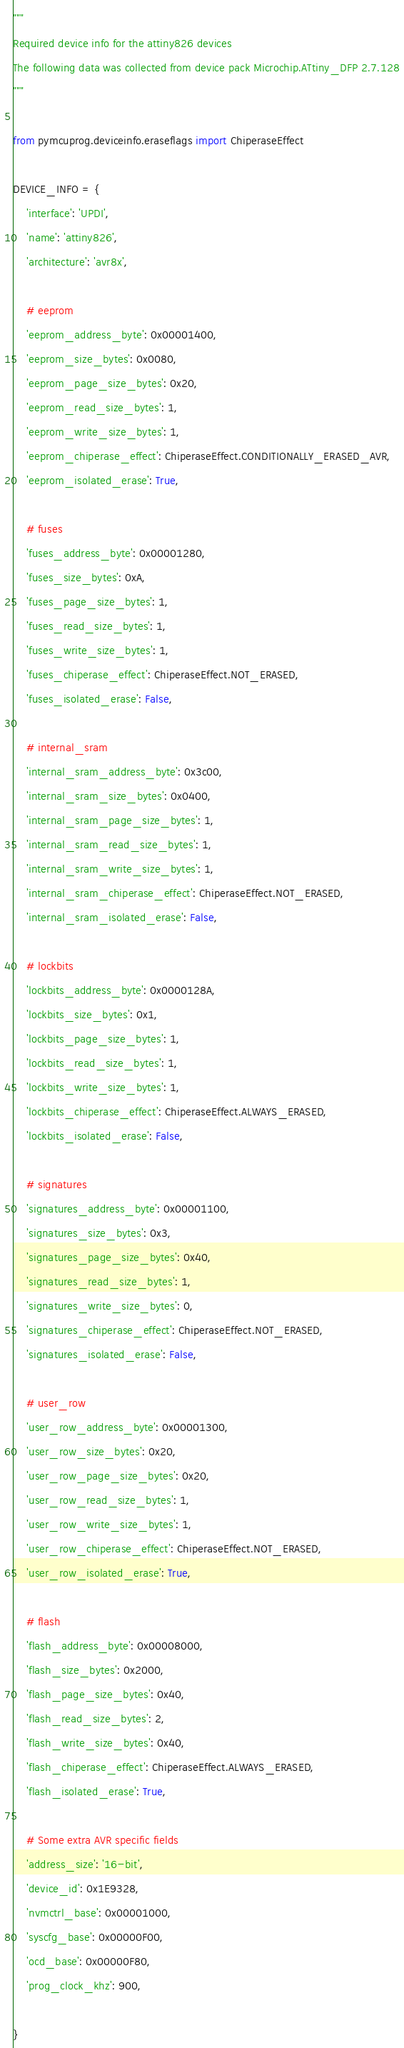Convert code to text. <code><loc_0><loc_0><loc_500><loc_500><_Python_>
"""
Required device info for the attiny826 devices
The following data was collected from device pack Microchip.ATtiny_DFP 2.7.128
"""

from pymcuprog.deviceinfo.eraseflags import ChiperaseEffect

DEVICE_INFO = {
    'interface': 'UPDI',
    'name': 'attiny826',
    'architecture': 'avr8x',

    # eeprom
    'eeprom_address_byte': 0x00001400,
    'eeprom_size_bytes': 0x0080,
    'eeprom_page_size_bytes': 0x20,
    'eeprom_read_size_bytes': 1,
    'eeprom_write_size_bytes': 1,
    'eeprom_chiperase_effect': ChiperaseEffect.CONDITIONALLY_ERASED_AVR,
    'eeprom_isolated_erase': True,

    # fuses
    'fuses_address_byte': 0x00001280,
    'fuses_size_bytes': 0xA,
    'fuses_page_size_bytes': 1,
    'fuses_read_size_bytes': 1,
    'fuses_write_size_bytes': 1,
    'fuses_chiperase_effect': ChiperaseEffect.NOT_ERASED,
    'fuses_isolated_erase': False,

    # internal_sram
    'internal_sram_address_byte': 0x3c00,
    'internal_sram_size_bytes': 0x0400,
    'internal_sram_page_size_bytes': 1,
    'internal_sram_read_size_bytes': 1,
    'internal_sram_write_size_bytes': 1,
    'internal_sram_chiperase_effect': ChiperaseEffect.NOT_ERASED,
    'internal_sram_isolated_erase': False,

    # lockbits
    'lockbits_address_byte': 0x0000128A,
    'lockbits_size_bytes': 0x1,
    'lockbits_page_size_bytes': 1,
    'lockbits_read_size_bytes': 1,
    'lockbits_write_size_bytes': 1,
    'lockbits_chiperase_effect': ChiperaseEffect.ALWAYS_ERASED,
    'lockbits_isolated_erase': False,

    # signatures
    'signatures_address_byte': 0x00001100,
    'signatures_size_bytes': 0x3,
    'signatures_page_size_bytes': 0x40,
    'signatures_read_size_bytes': 1,
    'signatures_write_size_bytes': 0,
    'signatures_chiperase_effect': ChiperaseEffect.NOT_ERASED,
    'signatures_isolated_erase': False,

    # user_row
    'user_row_address_byte': 0x00001300,
    'user_row_size_bytes': 0x20,
    'user_row_page_size_bytes': 0x20,
    'user_row_read_size_bytes': 1,
    'user_row_write_size_bytes': 1,
    'user_row_chiperase_effect': ChiperaseEffect.NOT_ERASED,
    'user_row_isolated_erase': True,

    # flash
    'flash_address_byte': 0x00008000,
    'flash_size_bytes': 0x2000,
    'flash_page_size_bytes': 0x40,
    'flash_read_size_bytes': 2,
    'flash_write_size_bytes': 0x40,
    'flash_chiperase_effect': ChiperaseEffect.ALWAYS_ERASED,
    'flash_isolated_erase': True,

    # Some extra AVR specific fields
    'address_size': '16-bit',
    'device_id': 0x1E9328,
    'nvmctrl_base': 0x00001000,
    'syscfg_base': 0x00000F00,
    'ocd_base': 0x00000F80,
    'prog_clock_khz': 900,

}
</code> 